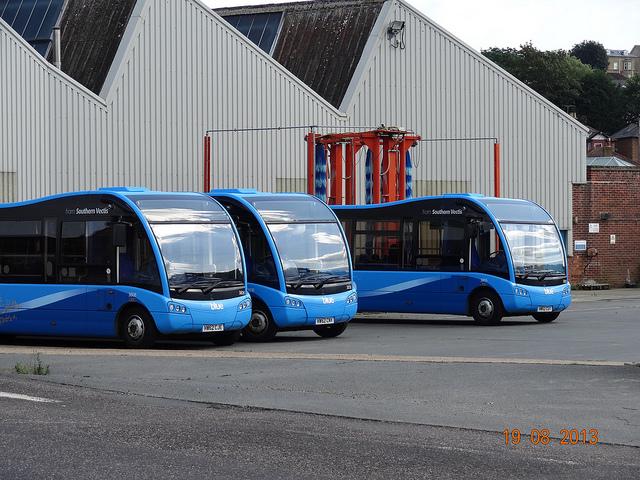How buses are there?
Quick response, please. 3. Are these buses all the same color?
Keep it brief. Yes. How many angles are on the roof of the building?
Write a very short answer. 3. 